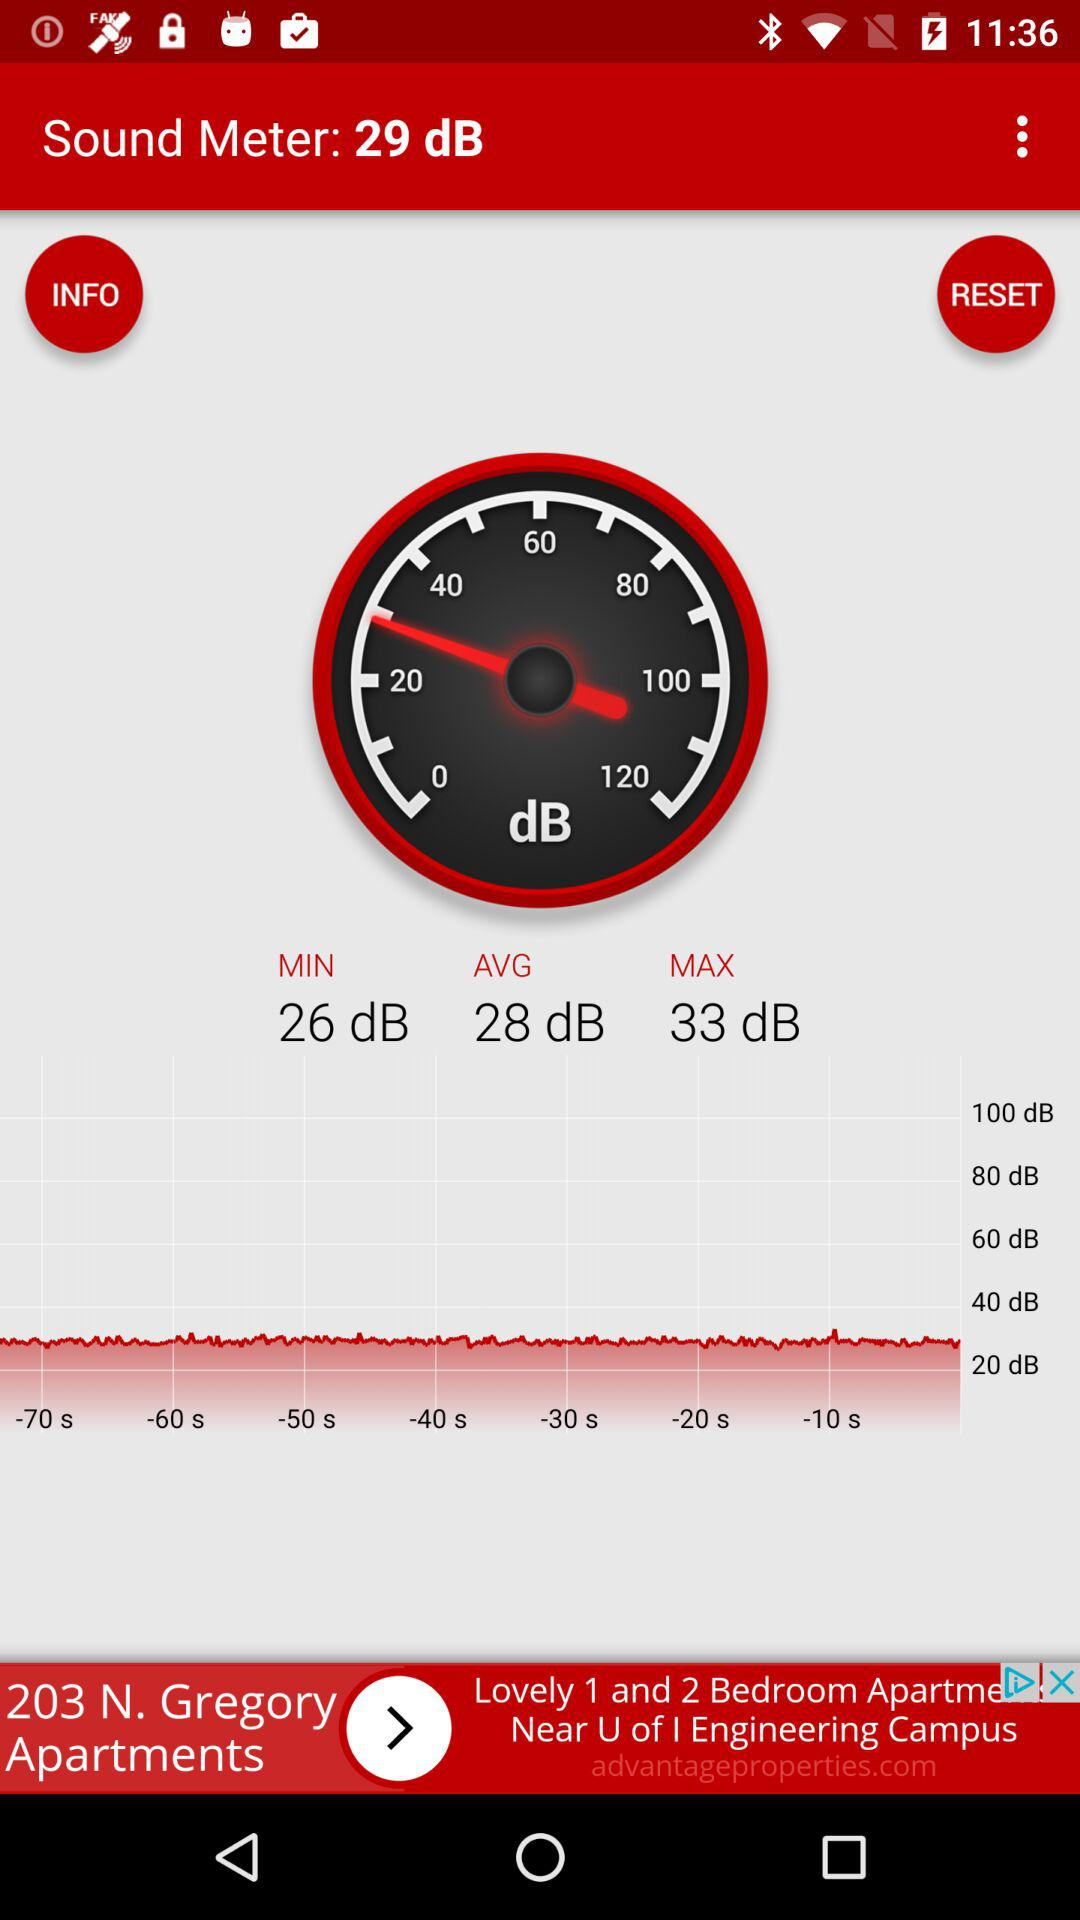What is the decibel reading on the sound meter? The decibel reading on the sound meter is 29 dB. 